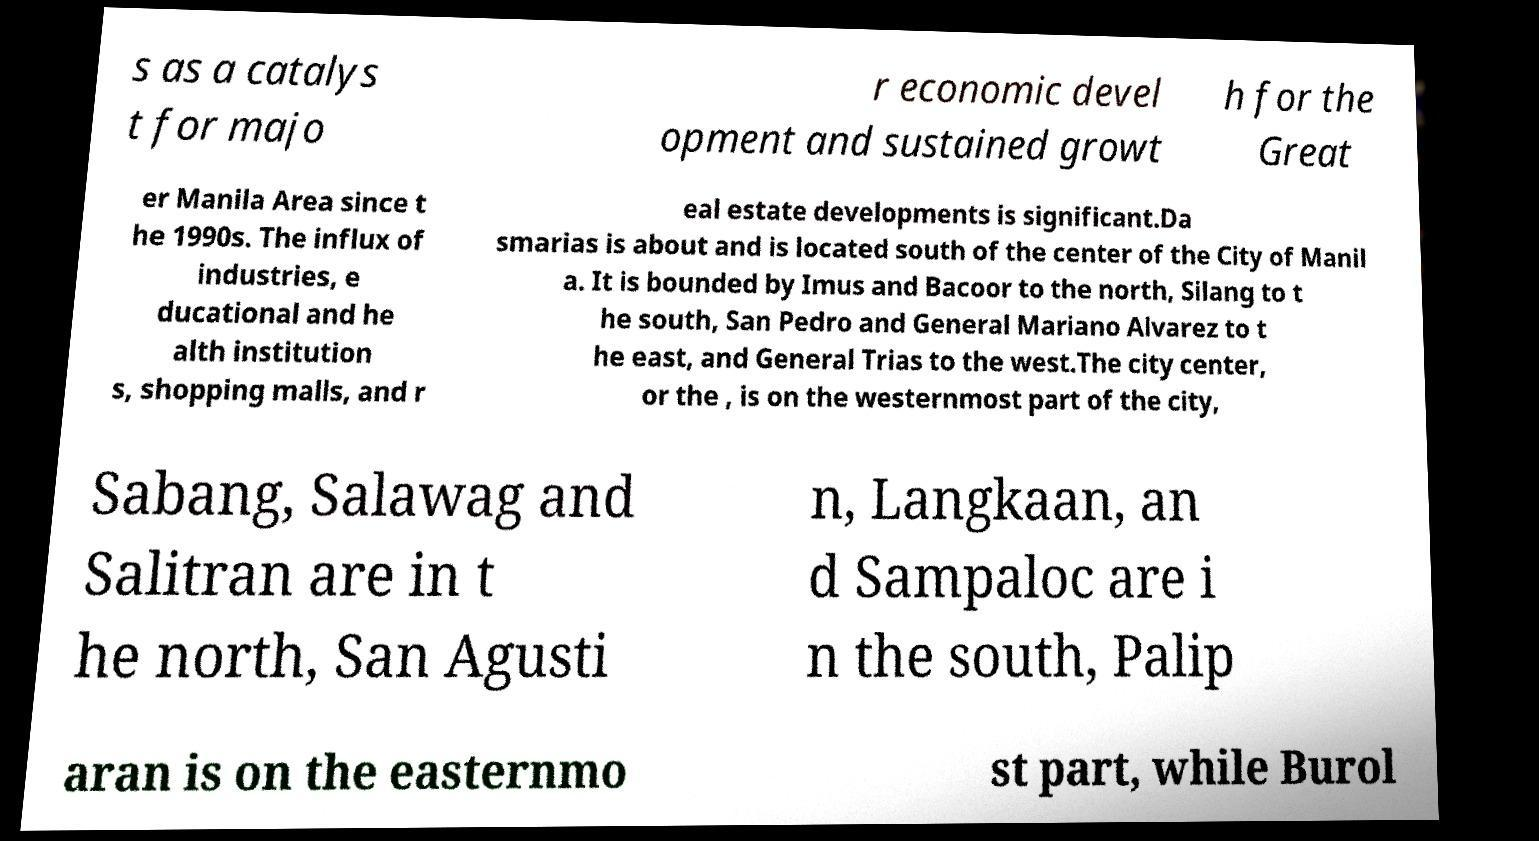Please read and relay the text visible in this image. What does it say? s as a catalys t for majo r economic devel opment and sustained growt h for the Great er Manila Area since t he 1990s. The influx of industries, e ducational and he alth institution s, shopping malls, and r eal estate developments is significant.Da smarias is about and is located south of the center of the City of Manil a. It is bounded by Imus and Bacoor to the north, Silang to t he south, San Pedro and General Mariano Alvarez to t he east, and General Trias to the west.The city center, or the , is on the westernmost part of the city, Sabang, Salawag and Salitran are in t he north, San Agusti n, Langkaan, an d Sampaloc are i n the south, Palip aran is on the easternmo st part, while Burol 